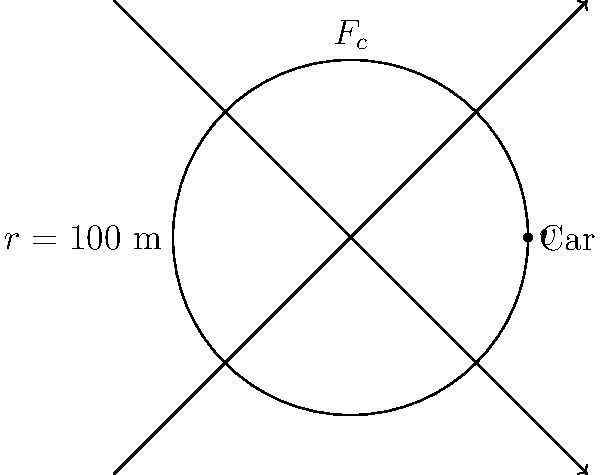Ryan Unzicker is racing on a circular dirt track with a radius of 100 meters. If his stock car weighs 800 kg and he's maintaining a constant speed of 20 m/s, what is the centripetal force experienced by Ryan during the race? To solve this problem, we'll use the formula for centripetal force:

$$F_c = \frac{mv^2}{r}$$

Where:
$F_c$ = centripetal force
$m$ = mass of the car
$v$ = velocity
$r$ = radius of the circular track

Given:
- Mass of the car, $m = 800$ kg
- Velocity, $v = 20$ m/s
- Radius of the track, $r = 100$ m

Let's substitute these values into the formula:

$$F_c = \frac{800 \text{ kg} \times (20 \text{ m/s})^2}{100 \text{ m}}$$

$$F_c = \frac{800 \times 400}{100} \text{ N}$$

$$F_c = 3,200 \text{ N}$$

Therefore, the centripetal force experienced by Ryan Unzicker during the race is 3,200 N or 3.2 kN.
Answer: 3,200 N 